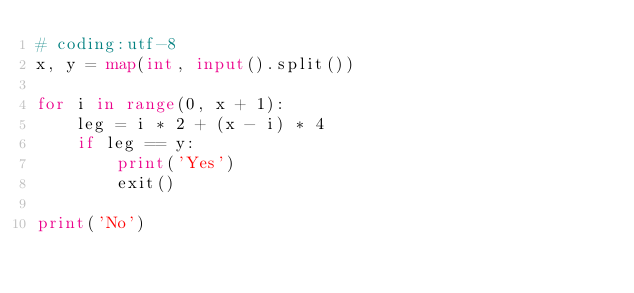<code> <loc_0><loc_0><loc_500><loc_500><_Python_># coding:utf-8
x, y = map(int, input().split())

for i in range(0, x + 1):
    leg = i * 2 + (x - i) * 4
    if leg == y:
        print('Yes')
        exit()

print('No')
</code> 